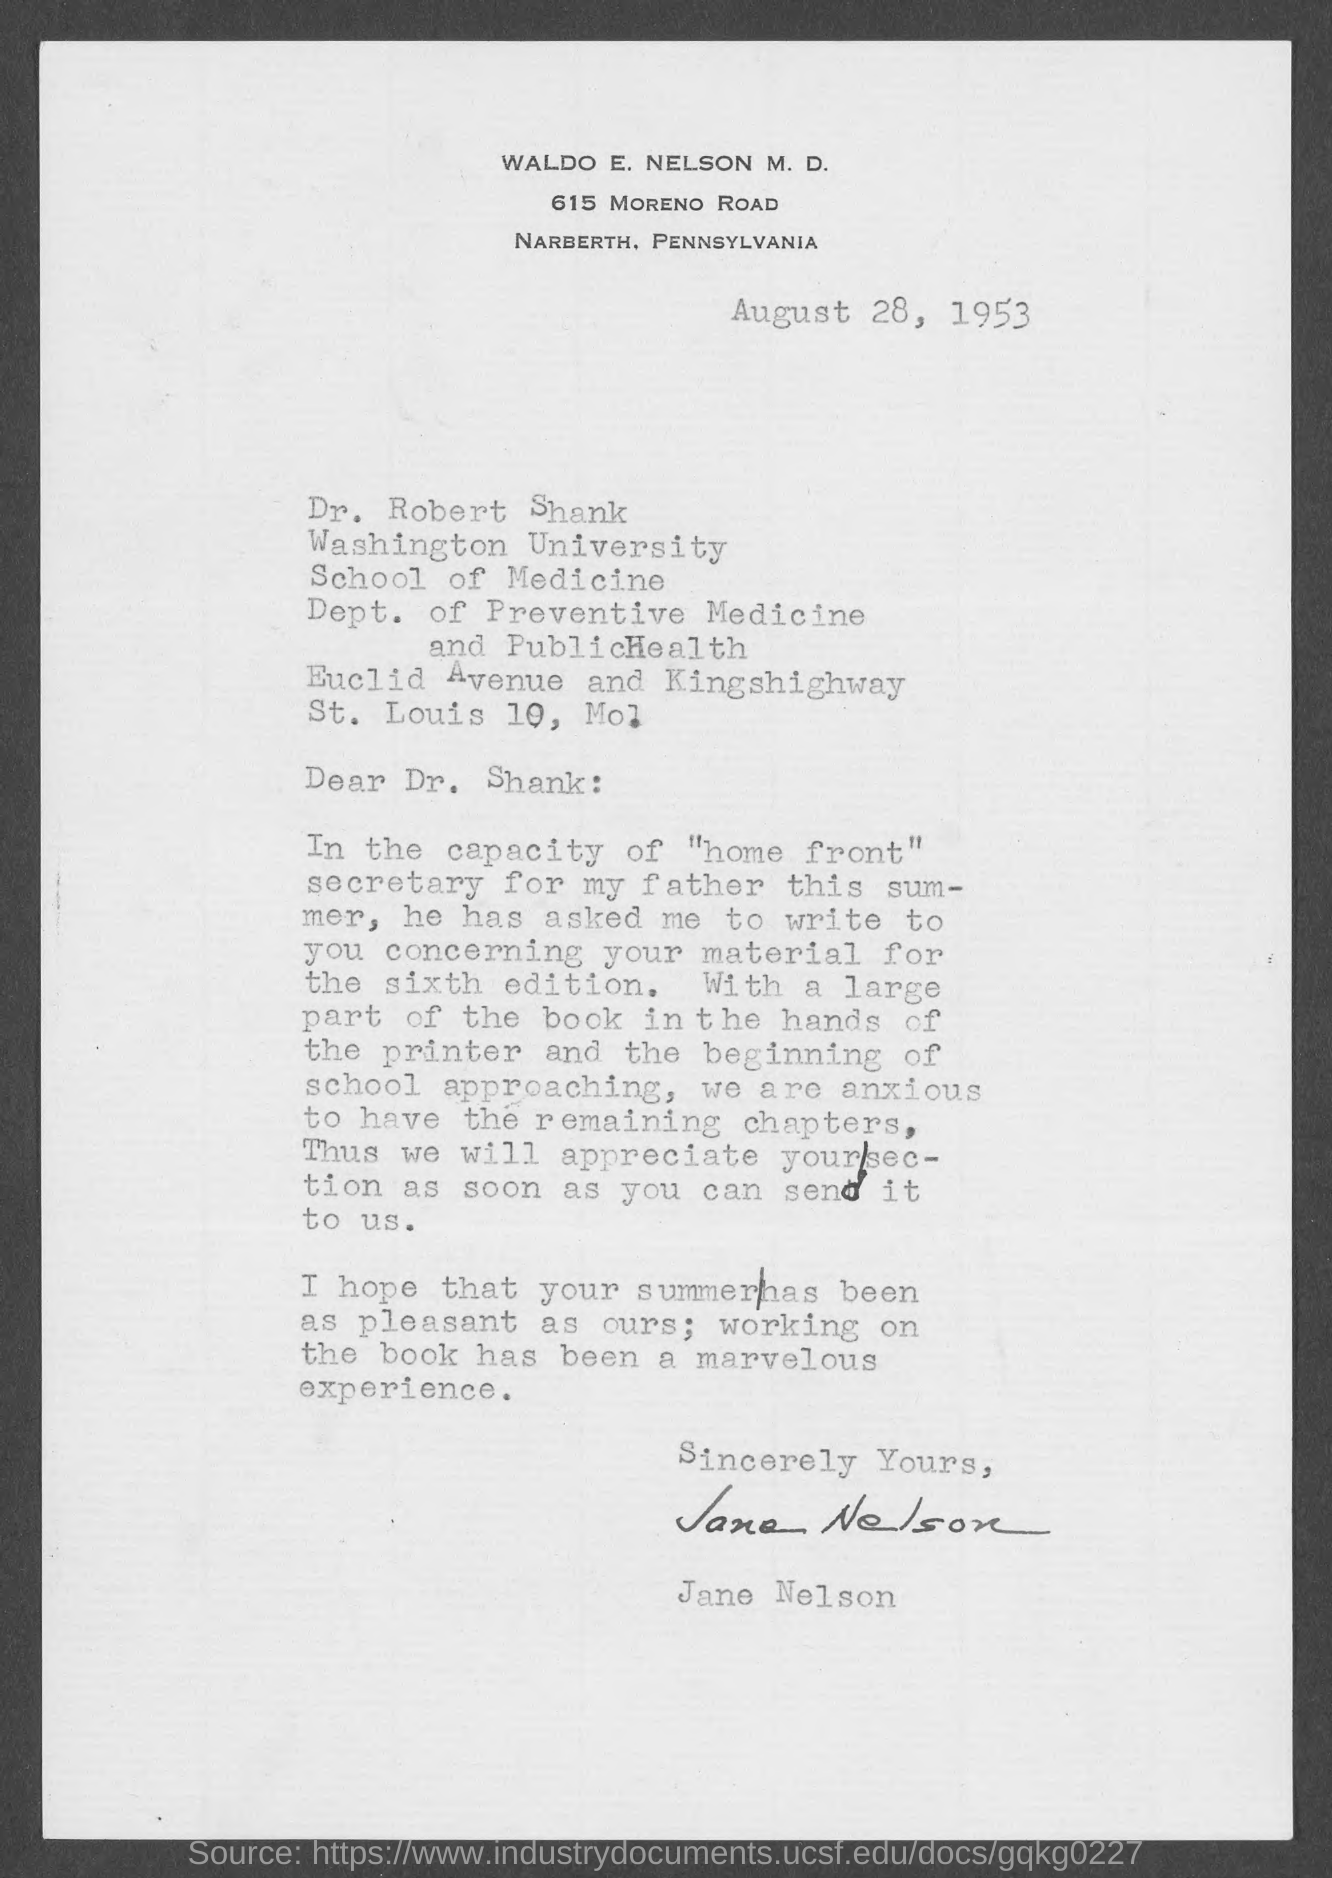When is the document dated?
Ensure brevity in your answer.  August 28, 1953. To whom is the letter addressed?
Provide a succinct answer. Dr. Shank. Who has signed the letter?
Your response must be concise. Jane Nelson. 